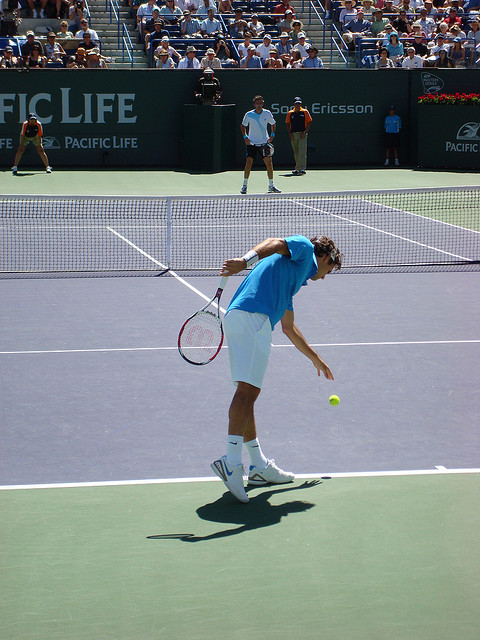Read all the text in this image. FIC LIFE PACIFIC LIFE Ericsson SONY PACIFICO FE 